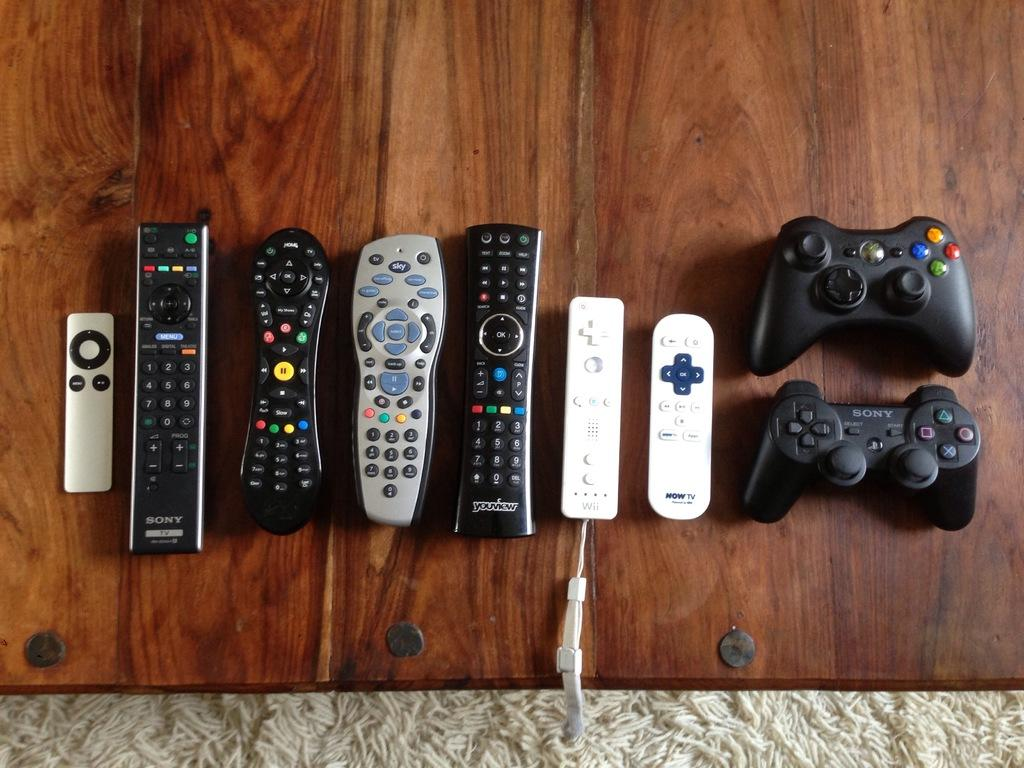<image>
Give a short and clear explanation of the subsequent image. A line of remotes with one of them that says 'NOW TV' 